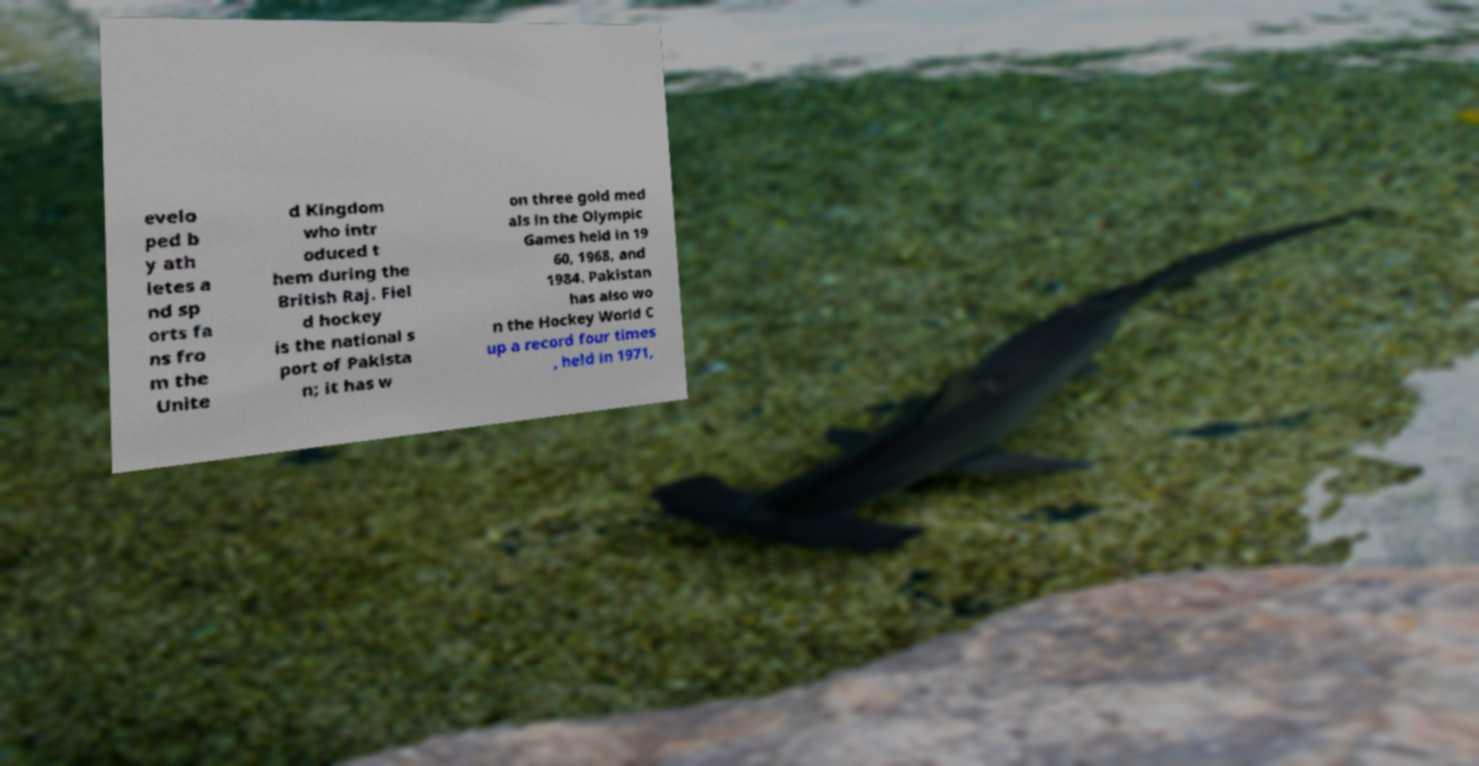There's text embedded in this image that I need extracted. Can you transcribe it verbatim? evelo ped b y ath letes a nd sp orts fa ns fro m the Unite d Kingdom who intr oduced t hem during the British Raj. Fiel d hockey is the national s port of Pakista n; it has w on three gold med als in the Olympic Games held in 19 60, 1968, and 1984. Pakistan has also wo n the Hockey World C up a record four times , held in 1971, 